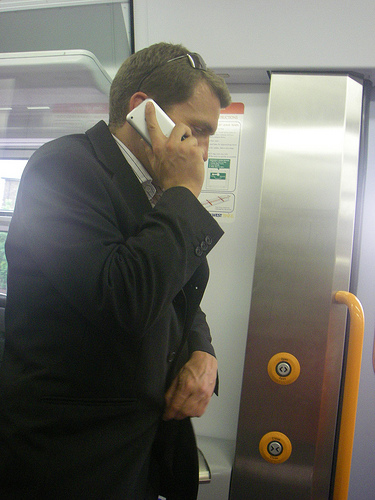What might the buttons and the panel beside the man be used for? The buttons and the panel beside the man are likely part of the train's control systems for passengers. They might include controls for requesting stops, opening the doors, or emergency response alerts to the train staff. 